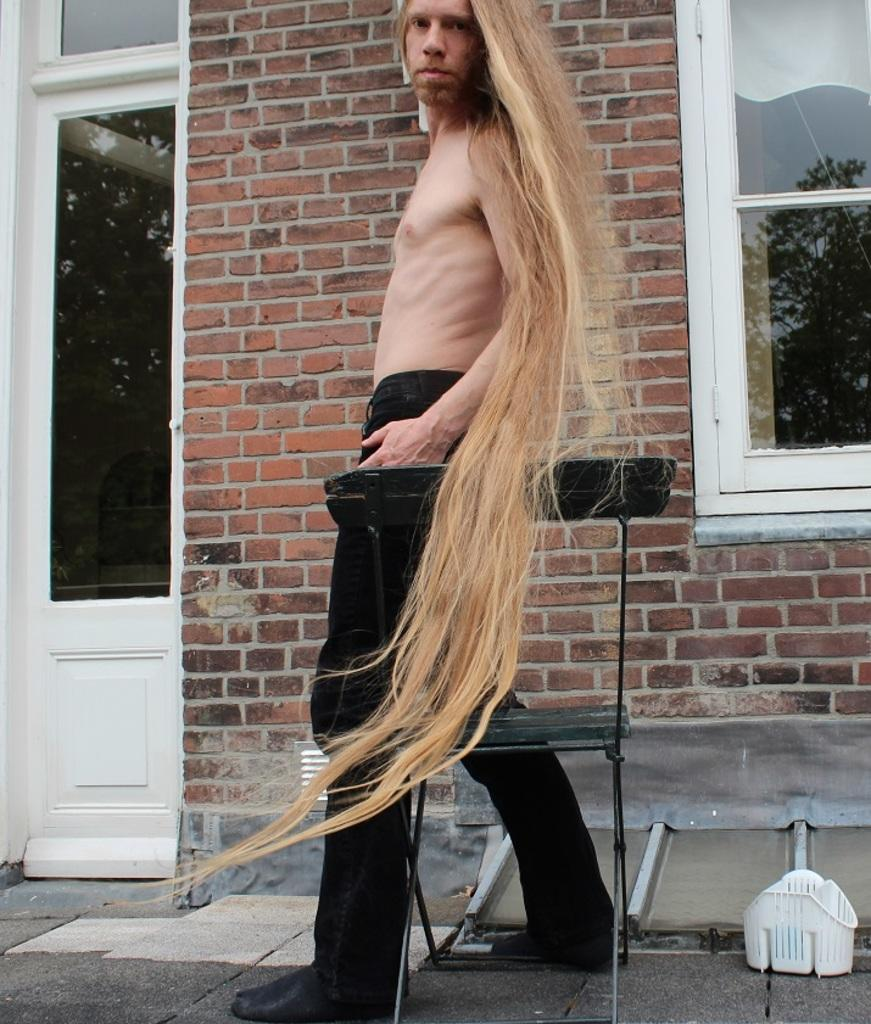What is the main subject in the image? There is a man standing in the image. What object can be seen near the man? There is a chair in the image. What is on the ground in the image? There is a white object on the ground. What can be seen in the background of the image? There is a brick wall, a window, and a door in the background of a building in the background of the image. What type of spark can be seen coming from the man's collar in the image? There is no spark or collar visible on the man in the image. 